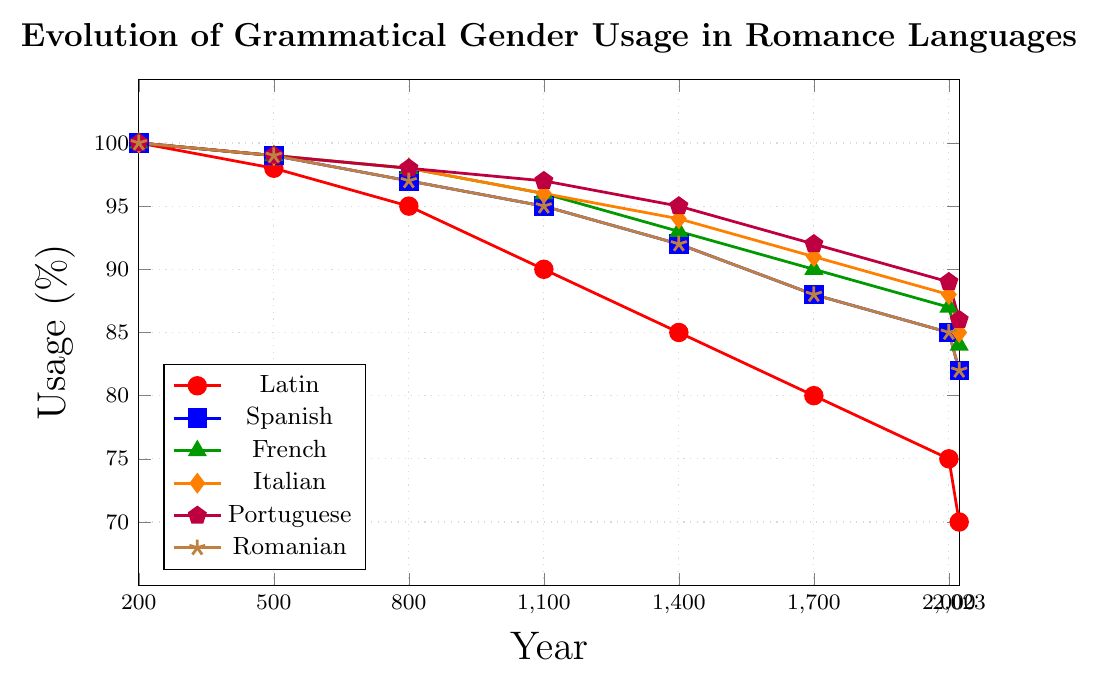What trend do we observe in the grammatical gender usage for all languages from the year 200 to 2023? The trend for all languages shows a steady decrease in grammatical gender usage over time. By examining the lines, it's visible that all lines slope downwards across the years 200 to 2023.
Answer: A steady decrease Which language shows the least decline in grammatical gender usage from 200 to 2023? To determine which language shows the least decline, we calculate the difference in usage percentage between the years 200 and 2023 for each language and compare. All differences are: Latin: 30%, Spanish: 18%, French: 16%, Italian: 15%, Portuguese: 14%, Romanian: 18%. The smallest decline is 14% for Portuguese.
Answer: Portuguese What is the average percentage of grammatical gender usage among all languages in the year 2000? To find the average, sum the percentages for all languages in the year 2000 and divide by the number of languages. The sum is 75 (Latin) + 85 (Spanish) + 87 (French) + 88 (Italian) + 89 (Portuguese) + 85 (Romanian) = 509. Dividing by 6 gives 509/6 ≈ 84.83.
Answer: 84.83 Between the years 1700 and 2000, which language had the steepest decline in grammatical gender usage? Calculate the difference in usage percentage for each language between the years 1700 and 2000, and identify the largest decline. The differences are: Latin: 80-75 = 5, Spanish: 88-85 = 3, French: 90-87 = 3, Italian: 91-88 = 3, Portuguese: 92-89 = 3, Romanian: 88-85 = 3. Latin has the steepest decline of 5%.
Answer: Latin Which language has the highest percentage of grammatical gender usage in the year 2023? From the data for the year 2023, compare the percentage values: Latin: 70, Spanish: 82, French: 84, Italian: 85, Portuguese: 86, Romanian: 82. Portuguese has the highest percentage of 86%.
Answer: Portuguese Identify the language that had the same grammatical gender usage in both years 1400 and 2023. By looking at the data, when comparing all language values for 1400 and 2023, we see Romanian had 92% in 1400 and 82% in 2023, which is not equal. French (93%, 84%), Italian (94%, 85%), Portuguese (95%, 86%), Latin (85%, 70%), and Spanish (92%, 82%) also differ. None have equal values in both years.
Answer: None What is the percentage change in grammatical gender usage for French from the year 800 to the year 1100? Calculate the percentage change using the formula [(new value - old value) / old value] * 100. For French, the values are 98 (800) and 96 (1100). Percentage change is [(96-98)/98]*100 = -2.04%.
Answer: -2.04% Which language's grammatical gender usage declined least rapidly between 1100 and 1700? Calculate the decline in usage percentage for each language from 1100 to 1700 and compare. The declines are: Latin: 90-80 = 10, Spanish: 95-88 = 7, French: 96-90 = 6, Italian: 96-91 = 5, Portuguese: 97-92 = 5, Romanian: 95-88 = 7. Portuguese and Italian declined least rapidly by 5%.
Answer: Portuguese and Italian Out of all the languages, which had the highest grammatical gender usage in 500? Looking at the data for the year 500: Latin: 98, Spanish: 99, French: 99, Italian: 99, Portuguese: 99, Romanian: 99. Spanish, French, Italian, Portuguese, and Romanian all had the highest usage of 99%.
Answer: Spanish, French, Italian, Portuguese, and Romanian 